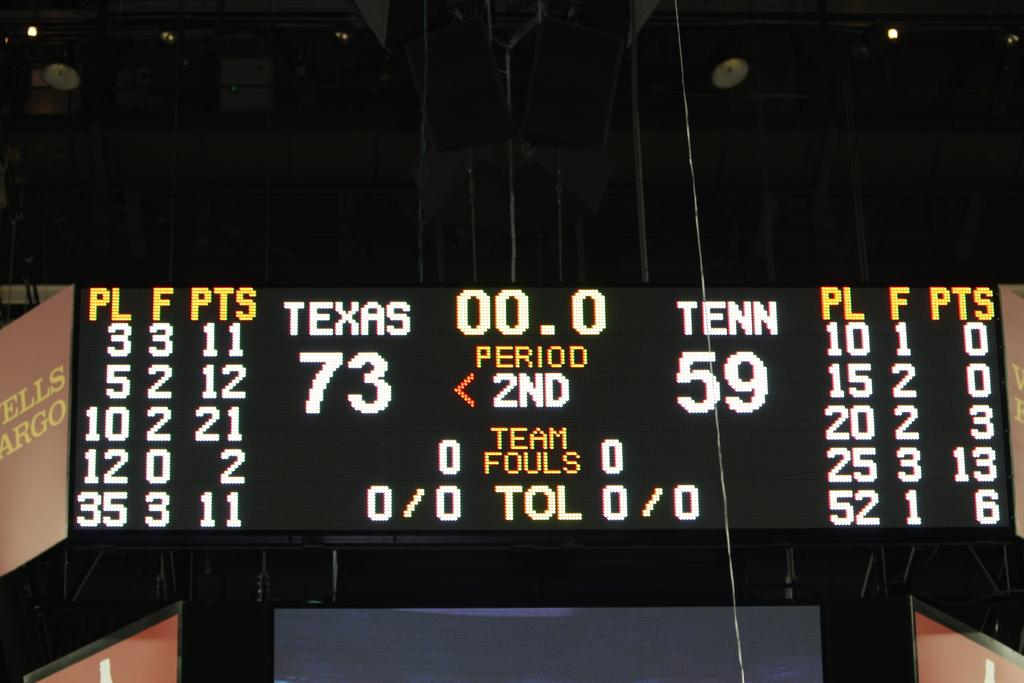What is the main object in the image? There is a board in the image. What type of information is present on the board? The board contains text and numbers. What is the color of the background in the image? The background of the image is dark. Can you observe any pump-related activities in the image? There is no reference to a pump or any pump-related activities in the image. What type of ear is visible on the board in the image? There is no ear present on the board or in the image. 